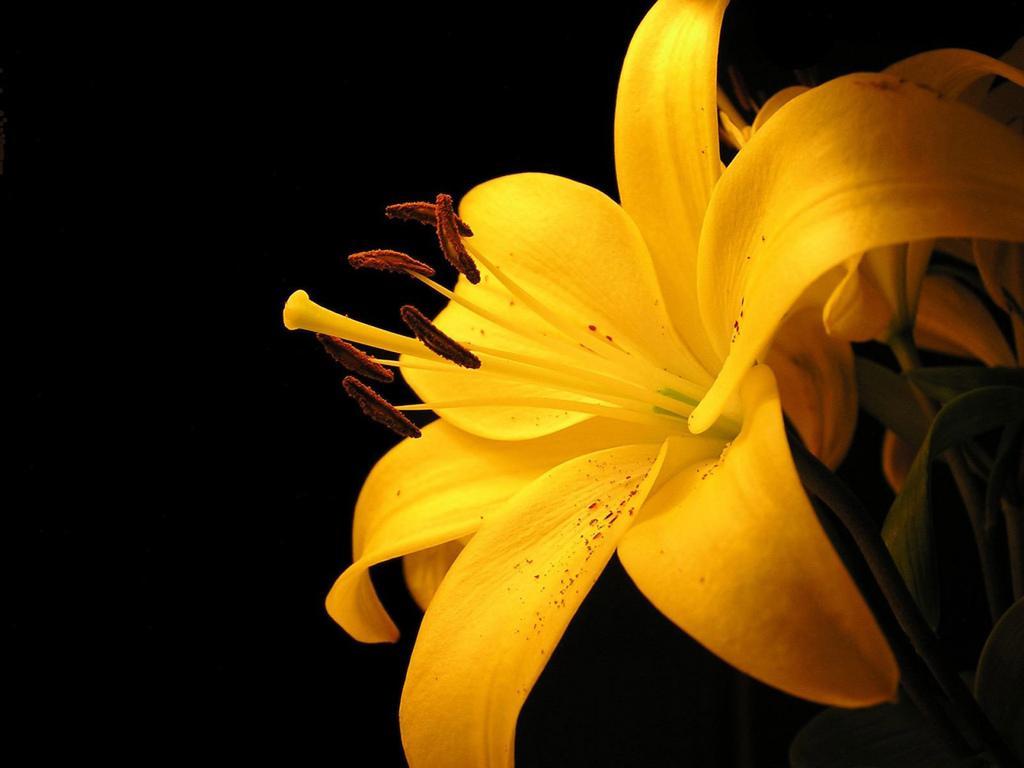Describe this image in one or two sentences. In this picture we can see a yellow color flower. 